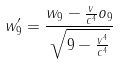Convert formula to latex. <formula><loc_0><loc_0><loc_500><loc_500>w _ { 9 } ^ { \prime } = \frac { w _ { 9 } - \frac { v } { c ^ { 4 } } o _ { 9 } } { \sqrt { 9 - \frac { v ^ { 4 } } { c ^ { 4 } } } }</formula> 